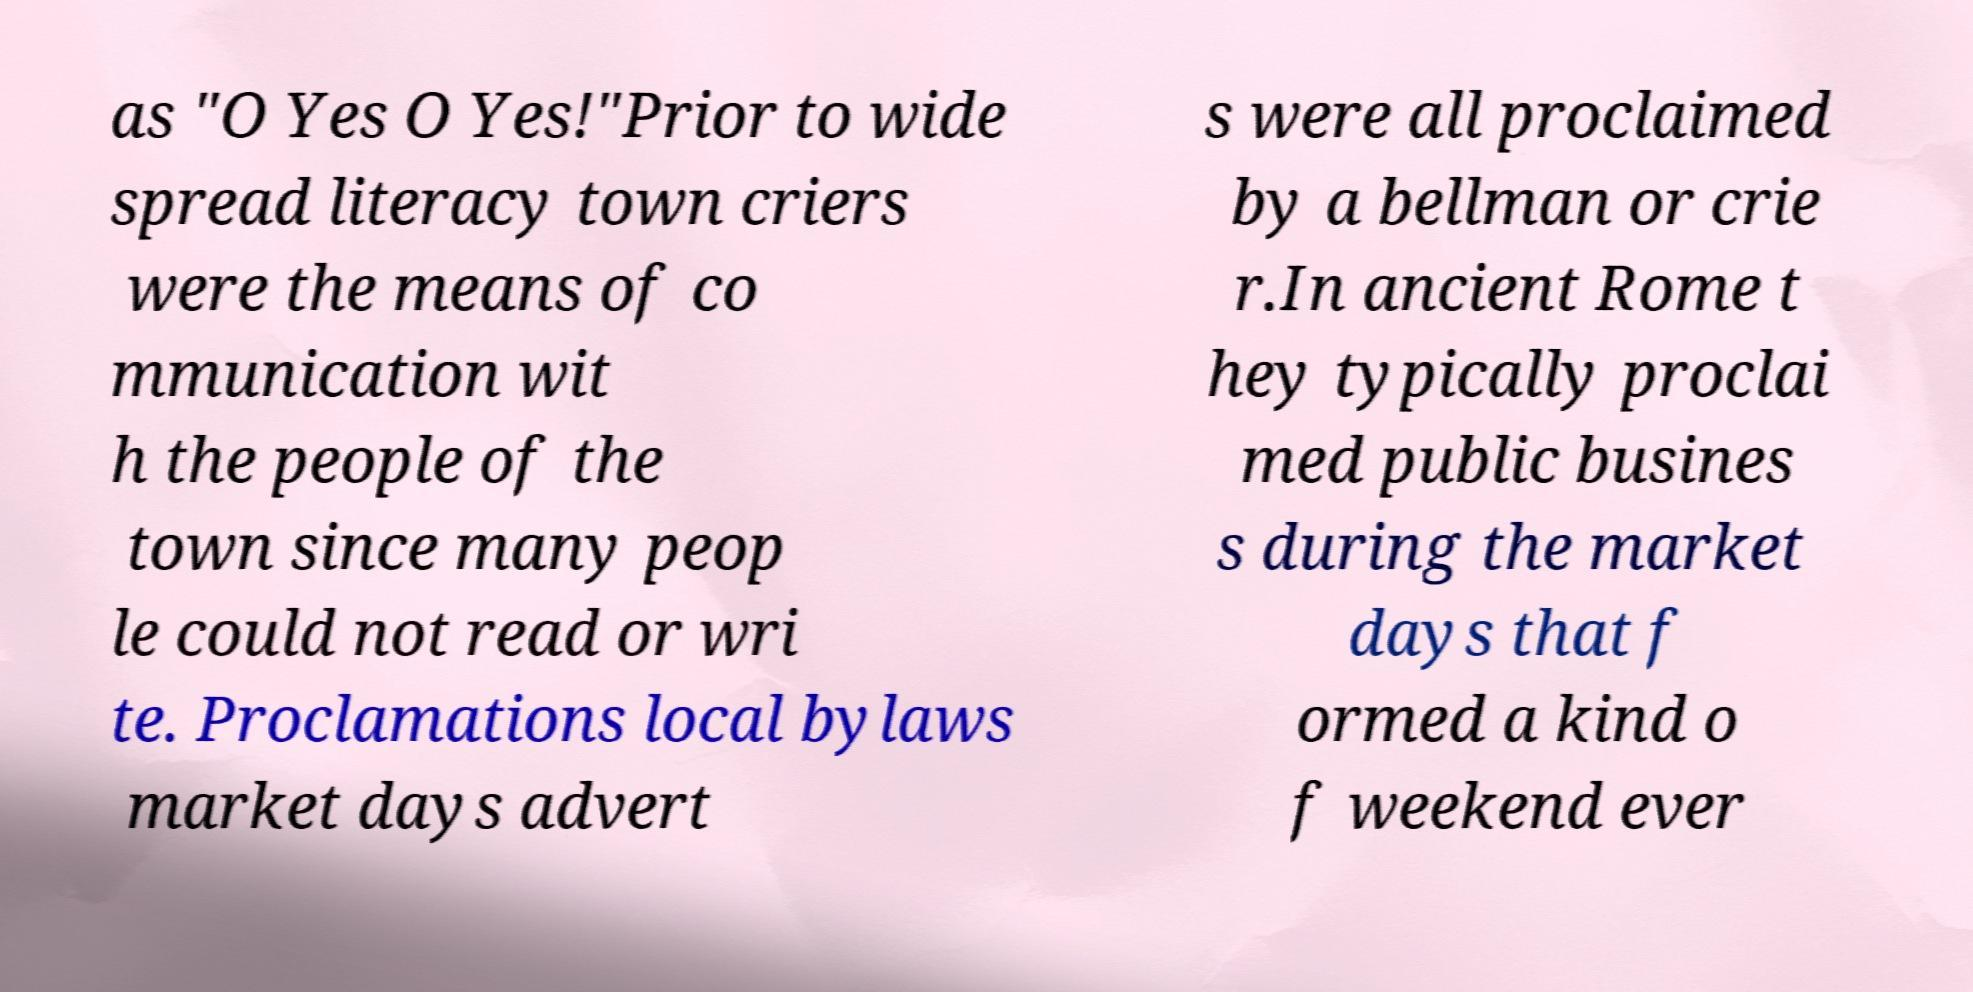I need the written content from this picture converted into text. Can you do that? as "O Yes O Yes!"Prior to wide spread literacy town criers were the means of co mmunication wit h the people of the town since many peop le could not read or wri te. Proclamations local bylaws market days advert s were all proclaimed by a bellman or crie r.In ancient Rome t hey typically proclai med public busines s during the market days that f ormed a kind o f weekend ever 